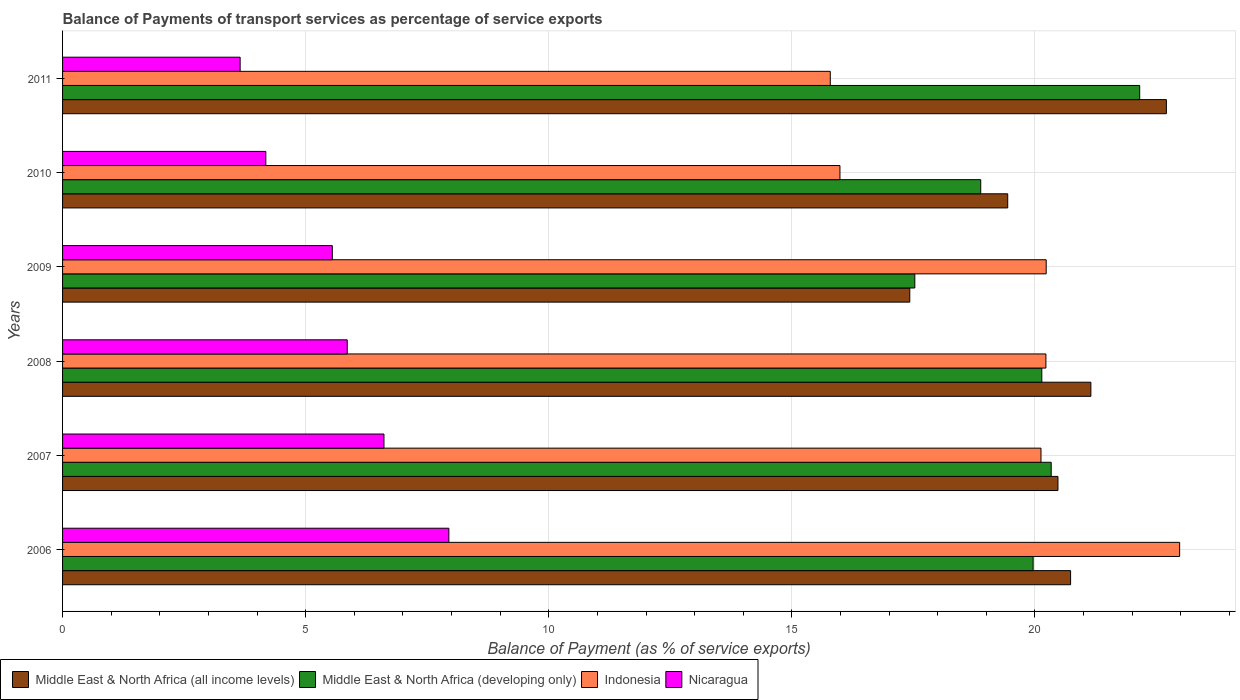How many groups of bars are there?
Offer a terse response. 6. Are the number of bars per tick equal to the number of legend labels?
Keep it short and to the point. Yes. How many bars are there on the 1st tick from the top?
Offer a terse response. 4. How many bars are there on the 4th tick from the bottom?
Make the answer very short. 4. What is the label of the 1st group of bars from the top?
Give a very brief answer. 2011. What is the balance of payments of transport services in Middle East & North Africa (developing only) in 2011?
Provide a succinct answer. 22.15. Across all years, what is the maximum balance of payments of transport services in Indonesia?
Provide a succinct answer. 22.98. Across all years, what is the minimum balance of payments of transport services in Middle East & North Africa (developing only)?
Offer a very short reply. 17.53. In which year was the balance of payments of transport services in Indonesia maximum?
Your answer should be compact. 2006. What is the total balance of payments of transport services in Middle East & North Africa (developing only) in the graph?
Offer a terse response. 119. What is the difference between the balance of payments of transport services in Nicaragua in 2007 and that in 2011?
Offer a terse response. 2.96. What is the difference between the balance of payments of transport services in Nicaragua in 2010 and the balance of payments of transport services in Middle East & North Africa (all income levels) in 2008?
Give a very brief answer. -16.97. What is the average balance of payments of transport services in Middle East & North Africa (developing only) per year?
Make the answer very short. 19.83. In the year 2010, what is the difference between the balance of payments of transport services in Middle East & North Africa (developing only) and balance of payments of transport services in Nicaragua?
Keep it short and to the point. 14.7. What is the ratio of the balance of payments of transport services in Nicaragua in 2006 to that in 2009?
Your answer should be very brief. 1.43. Is the balance of payments of transport services in Middle East & North Africa (developing only) in 2009 less than that in 2010?
Make the answer very short. Yes. What is the difference between the highest and the second highest balance of payments of transport services in Middle East & North Africa (all income levels)?
Ensure brevity in your answer.  1.55. What is the difference between the highest and the lowest balance of payments of transport services in Middle East & North Africa (developing only)?
Offer a terse response. 4.63. Is the sum of the balance of payments of transport services in Middle East & North Africa (all income levels) in 2009 and 2010 greater than the maximum balance of payments of transport services in Middle East & North Africa (developing only) across all years?
Ensure brevity in your answer.  Yes. Is it the case that in every year, the sum of the balance of payments of transport services in Middle East & North Africa (developing only) and balance of payments of transport services in Nicaragua is greater than the sum of balance of payments of transport services in Middle East & North Africa (all income levels) and balance of payments of transport services in Indonesia?
Offer a very short reply. Yes. What does the 4th bar from the bottom in 2010 represents?
Your answer should be compact. Nicaragua. How many years are there in the graph?
Give a very brief answer. 6. Are the values on the major ticks of X-axis written in scientific E-notation?
Ensure brevity in your answer.  No. Does the graph contain any zero values?
Make the answer very short. No. Does the graph contain grids?
Ensure brevity in your answer.  Yes. Where does the legend appear in the graph?
Your answer should be very brief. Bottom left. How many legend labels are there?
Provide a short and direct response. 4. How are the legend labels stacked?
Give a very brief answer. Horizontal. What is the title of the graph?
Offer a very short reply. Balance of Payments of transport services as percentage of service exports. What is the label or title of the X-axis?
Give a very brief answer. Balance of Payment (as % of service exports). What is the Balance of Payment (as % of service exports) in Middle East & North Africa (all income levels) in 2006?
Give a very brief answer. 20.73. What is the Balance of Payment (as % of service exports) of Middle East & North Africa (developing only) in 2006?
Provide a succinct answer. 19.96. What is the Balance of Payment (as % of service exports) of Indonesia in 2006?
Offer a terse response. 22.98. What is the Balance of Payment (as % of service exports) in Nicaragua in 2006?
Ensure brevity in your answer.  7.95. What is the Balance of Payment (as % of service exports) in Middle East & North Africa (all income levels) in 2007?
Offer a terse response. 20.47. What is the Balance of Payment (as % of service exports) in Middle East & North Africa (developing only) in 2007?
Provide a succinct answer. 20.33. What is the Balance of Payment (as % of service exports) of Indonesia in 2007?
Provide a short and direct response. 20.12. What is the Balance of Payment (as % of service exports) of Nicaragua in 2007?
Provide a short and direct response. 6.61. What is the Balance of Payment (as % of service exports) of Middle East & North Africa (all income levels) in 2008?
Provide a short and direct response. 21.15. What is the Balance of Payment (as % of service exports) in Middle East & North Africa (developing only) in 2008?
Offer a very short reply. 20.14. What is the Balance of Payment (as % of service exports) in Indonesia in 2008?
Give a very brief answer. 20.22. What is the Balance of Payment (as % of service exports) of Nicaragua in 2008?
Offer a very short reply. 5.85. What is the Balance of Payment (as % of service exports) of Middle East & North Africa (all income levels) in 2009?
Your response must be concise. 17.43. What is the Balance of Payment (as % of service exports) of Middle East & North Africa (developing only) in 2009?
Your response must be concise. 17.53. What is the Balance of Payment (as % of service exports) in Indonesia in 2009?
Keep it short and to the point. 20.23. What is the Balance of Payment (as % of service exports) in Nicaragua in 2009?
Provide a short and direct response. 5.55. What is the Balance of Payment (as % of service exports) of Middle East & North Africa (all income levels) in 2010?
Make the answer very short. 19.44. What is the Balance of Payment (as % of service exports) of Middle East & North Africa (developing only) in 2010?
Your response must be concise. 18.88. What is the Balance of Payment (as % of service exports) of Indonesia in 2010?
Provide a short and direct response. 15.99. What is the Balance of Payment (as % of service exports) of Nicaragua in 2010?
Your response must be concise. 4.18. What is the Balance of Payment (as % of service exports) in Middle East & North Africa (all income levels) in 2011?
Your answer should be compact. 22.7. What is the Balance of Payment (as % of service exports) in Middle East & North Africa (developing only) in 2011?
Your answer should be compact. 22.15. What is the Balance of Payment (as % of service exports) of Indonesia in 2011?
Offer a very short reply. 15.79. What is the Balance of Payment (as % of service exports) of Nicaragua in 2011?
Offer a very short reply. 3.65. Across all years, what is the maximum Balance of Payment (as % of service exports) in Middle East & North Africa (all income levels)?
Give a very brief answer. 22.7. Across all years, what is the maximum Balance of Payment (as % of service exports) of Middle East & North Africa (developing only)?
Offer a terse response. 22.15. Across all years, what is the maximum Balance of Payment (as % of service exports) of Indonesia?
Your response must be concise. 22.98. Across all years, what is the maximum Balance of Payment (as % of service exports) of Nicaragua?
Provide a short and direct response. 7.95. Across all years, what is the minimum Balance of Payment (as % of service exports) in Middle East & North Africa (all income levels)?
Offer a terse response. 17.43. Across all years, what is the minimum Balance of Payment (as % of service exports) of Middle East & North Africa (developing only)?
Provide a short and direct response. 17.53. Across all years, what is the minimum Balance of Payment (as % of service exports) in Indonesia?
Ensure brevity in your answer.  15.79. Across all years, what is the minimum Balance of Payment (as % of service exports) in Nicaragua?
Your answer should be compact. 3.65. What is the total Balance of Payment (as % of service exports) in Middle East & North Africa (all income levels) in the graph?
Make the answer very short. 121.92. What is the total Balance of Payment (as % of service exports) of Middle East & North Africa (developing only) in the graph?
Provide a short and direct response. 119. What is the total Balance of Payment (as % of service exports) of Indonesia in the graph?
Offer a very short reply. 115.33. What is the total Balance of Payment (as % of service exports) in Nicaragua in the graph?
Make the answer very short. 33.79. What is the difference between the Balance of Payment (as % of service exports) in Middle East & North Africa (all income levels) in 2006 and that in 2007?
Offer a terse response. 0.26. What is the difference between the Balance of Payment (as % of service exports) in Middle East & North Africa (developing only) in 2006 and that in 2007?
Offer a very short reply. -0.37. What is the difference between the Balance of Payment (as % of service exports) of Indonesia in 2006 and that in 2007?
Your answer should be very brief. 2.85. What is the difference between the Balance of Payment (as % of service exports) of Nicaragua in 2006 and that in 2007?
Offer a terse response. 1.33. What is the difference between the Balance of Payment (as % of service exports) in Middle East & North Africa (all income levels) in 2006 and that in 2008?
Ensure brevity in your answer.  -0.42. What is the difference between the Balance of Payment (as % of service exports) in Middle East & North Africa (developing only) in 2006 and that in 2008?
Offer a terse response. -0.18. What is the difference between the Balance of Payment (as % of service exports) in Indonesia in 2006 and that in 2008?
Your answer should be very brief. 2.75. What is the difference between the Balance of Payment (as % of service exports) of Nicaragua in 2006 and that in 2008?
Your answer should be compact. 2.09. What is the difference between the Balance of Payment (as % of service exports) of Middle East & North Africa (all income levels) in 2006 and that in 2009?
Provide a succinct answer. 3.31. What is the difference between the Balance of Payment (as % of service exports) in Middle East & North Africa (developing only) in 2006 and that in 2009?
Make the answer very short. 2.43. What is the difference between the Balance of Payment (as % of service exports) in Indonesia in 2006 and that in 2009?
Make the answer very short. 2.74. What is the difference between the Balance of Payment (as % of service exports) of Nicaragua in 2006 and that in 2009?
Your answer should be very brief. 2.4. What is the difference between the Balance of Payment (as % of service exports) of Middle East & North Africa (all income levels) in 2006 and that in 2010?
Offer a very short reply. 1.29. What is the difference between the Balance of Payment (as % of service exports) of Middle East & North Africa (developing only) in 2006 and that in 2010?
Keep it short and to the point. 1.08. What is the difference between the Balance of Payment (as % of service exports) in Indonesia in 2006 and that in 2010?
Offer a terse response. 6.99. What is the difference between the Balance of Payment (as % of service exports) in Nicaragua in 2006 and that in 2010?
Your response must be concise. 3.76. What is the difference between the Balance of Payment (as % of service exports) in Middle East & North Africa (all income levels) in 2006 and that in 2011?
Provide a succinct answer. -1.97. What is the difference between the Balance of Payment (as % of service exports) of Middle East & North Africa (developing only) in 2006 and that in 2011?
Offer a terse response. -2.19. What is the difference between the Balance of Payment (as % of service exports) of Indonesia in 2006 and that in 2011?
Your response must be concise. 7.19. What is the difference between the Balance of Payment (as % of service exports) of Nicaragua in 2006 and that in 2011?
Provide a succinct answer. 4.29. What is the difference between the Balance of Payment (as % of service exports) of Middle East & North Africa (all income levels) in 2007 and that in 2008?
Provide a short and direct response. -0.68. What is the difference between the Balance of Payment (as % of service exports) in Middle East & North Africa (developing only) in 2007 and that in 2008?
Ensure brevity in your answer.  0.19. What is the difference between the Balance of Payment (as % of service exports) of Indonesia in 2007 and that in 2008?
Provide a succinct answer. -0.1. What is the difference between the Balance of Payment (as % of service exports) in Nicaragua in 2007 and that in 2008?
Your answer should be compact. 0.76. What is the difference between the Balance of Payment (as % of service exports) of Middle East & North Africa (all income levels) in 2007 and that in 2009?
Provide a short and direct response. 3.05. What is the difference between the Balance of Payment (as % of service exports) in Middle East & North Africa (developing only) in 2007 and that in 2009?
Ensure brevity in your answer.  2.81. What is the difference between the Balance of Payment (as % of service exports) in Indonesia in 2007 and that in 2009?
Your answer should be compact. -0.11. What is the difference between the Balance of Payment (as % of service exports) of Nicaragua in 2007 and that in 2009?
Your answer should be compact. 1.06. What is the difference between the Balance of Payment (as % of service exports) of Middle East & North Africa (all income levels) in 2007 and that in 2010?
Your answer should be compact. 1.03. What is the difference between the Balance of Payment (as % of service exports) in Middle East & North Africa (developing only) in 2007 and that in 2010?
Your answer should be compact. 1.45. What is the difference between the Balance of Payment (as % of service exports) in Indonesia in 2007 and that in 2010?
Give a very brief answer. 4.13. What is the difference between the Balance of Payment (as % of service exports) in Nicaragua in 2007 and that in 2010?
Keep it short and to the point. 2.43. What is the difference between the Balance of Payment (as % of service exports) of Middle East & North Africa (all income levels) in 2007 and that in 2011?
Offer a very short reply. -2.23. What is the difference between the Balance of Payment (as % of service exports) in Middle East & North Africa (developing only) in 2007 and that in 2011?
Provide a succinct answer. -1.82. What is the difference between the Balance of Payment (as % of service exports) of Indonesia in 2007 and that in 2011?
Ensure brevity in your answer.  4.33. What is the difference between the Balance of Payment (as % of service exports) in Nicaragua in 2007 and that in 2011?
Your response must be concise. 2.96. What is the difference between the Balance of Payment (as % of service exports) in Middle East & North Africa (all income levels) in 2008 and that in 2009?
Offer a very short reply. 3.72. What is the difference between the Balance of Payment (as % of service exports) of Middle East & North Africa (developing only) in 2008 and that in 2009?
Your answer should be compact. 2.61. What is the difference between the Balance of Payment (as % of service exports) in Indonesia in 2008 and that in 2009?
Your answer should be very brief. -0.01. What is the difference between the Balance of Payment (as % of service exports) in Nicaragua in 2008 and that in 2009?
Offer a terse response. 0.31. What is the difference between the Balance of Payment (as % of service exports) of Middle East & North Africa (all income levels) in 2008 and that in 2010?
Offer a terse response. 1.71. What is the difference between the Balance of Payment (as % of service exports) in Middle East & North Africa (developing only) in 2008 and that in 2010?
Your answer should be very brief. 1.26. What is the difference between the Balance of Payment (as % of service exports) of Indonesia in 2008 and that in 2010?
Offer a very short reply. 4.24. What is the difference between the Balance of Payment (as % of service exports) of Nicaragua in 2008 and that in 2010?
Give a very brief answer. 1.67. What is the difference between the Balance of Payment (as % of service exports) in Middle East & North Africa (all income levels) in 2008 and that in 2011?
Ensure brevity in your answer.  -1.55. What is the difference between the Balance of Payment (as % of service exports) in Middle East & North Africa (developing only) in 2008 and that in 2011?
Your answer should be compact. -2.01. What is the difference between the Balance of Payment (as % of service exports) of Indonesia in 2008 and that in 2011?
Offer a terse response. 4.43. What is the difference between the Balance of Payment (as % of service exports) in Nicaragua in 2008 and that in 2011?
Provide a short and direct response. 2.2. What is the difference between the Balance of Payment (as % of service exports) in Middle East & North Africa (all income levels) in 2009 and that in 2010?
Your response must be concise. -2.01. What is the difference between the Balance of Payment (as % of service exports) in Middle East & North Africa (developing only) in 2009 and that in 2010?
Make the answer very short. -1.36. What is the difference between the Balance of Payment (as % of service exports) in Indonesia in 2009 and that in 2010?
Ensure brevity in your answer.  4.24. What is the difference between the Balance of Payment (as % of service exports) in Nicaragua in 2009 and that in 2010?
Your answer should be very brief. 1.37. What is the difference between the Balance of Payment (as % of service exports) of Middle East & North Africa (all income levels) in 2009 and that in 2011?
Your answer should be very brief. -5.28. What is the difference between the Balance of Payment (as % of service exports) of Middle East & North Africa (developing only) in 2009 and that in 2011?
Make the answer very short. -4.63. What is the difference between the Balance of Payment (as % of service exports) of Indonesia in 2009 and that in 2011?
Your answer should be very brief. 4.44. What is the difference between the Balance of Payment (as % of service exports) of Nicaragua in 2009 and that in 2011?
Provide a short and direct response. 1.9. What is the difference between the Balance of Payment (as % of service exports) of Middle East & North Africa (all income levels) in 2010 and that in 2011?
Your response must be concise. -3.26. What is the difference between the Balance of Payment (as % of service exports) of Middle East & North Africa (developing only) in 2010 and that in 2011?
Your answer should be very brief. -3.27. What is the difference between the Balance of Payment (as % of service exports) of Indonesia in 2010 and that in 2011?
Your answer should be very brief. 0.2. What is the difference between the Balance of Payment (as % of service exports) in Nicaragua in 2010 and that in 2011?
Keep it short and to the point. 0.53. What is the difference between the Balance of Payment (as % of service exports) in Middle East & North Africa (all income levels) in 2006 and the Balance of Payment (as % of service exports) in Middle East & North Africa (developing only) in 2007?
Keep it short and to the point. 0.4. What is the difference between the Balance of Payment (as % of service exports) of Middle East & North Africa (all income levels) in 2006 and the Balance of Payment (as % of service exports) of Indonesia in 2007?
Provide a short and direct response. 0.61. What is the difference between the Balance of Payment (as % of service exports) in Middle East & North Africa (all income levels) in 2006 and the Balance of Payment (as % of service exports) in Nicaragua in 2007?
Provide a succinct answer. 14.12. What is the difference between the Balance of Payment (as % of service exports) in Middle East & North Africa (developing only) in 2006 and the Balance of Payment (as % of service exports) in Indonesia in 2007?
Give a very brief answer. -0.16. What is the difference between the Balance of Payment (as % of service exports) of Middle East & North Africa (developing only) in 2006 and the Balance of Payment (as % of service exports) of Nicaragua in 2007?
Provide a short and direct response. 13.35. What is the difference between the Balance of Payment (as % of service exports) of Indonesia in 2006 and the Balance of Payment (as % of service exports) of Nicaragua in 2007?
Make the answer very short. 16.36. What is the difference between the Balance of Payment (as % of service exports) of Middle East & North Africa (all income levels) in 2006 and the Balance of Payment (as % of service exports) of Middle East & North Africa (developing only) in 2008?
Your response must be concise. 0.59. What is the difference between the Balance of Payment (as % of service exports) in Middle East & North Africa (all income levels) in 2006 and the Balance of Payment (as % of service exports) in Indonesia in 2008?
Your answer should be compact. 0.51. What is the difference between the Balance of Payment (as % of service exports) in Middle East & North Africa (all income levels) in 2006 and the Balance of Payment (as % of service exports) in Nicaragua in 2008?
Your response must be concise. 14.88. What is the difference between the Balance of Payment (as % of service exports) in Middle East & North Africa (developing only) in 2006 and the Balance of Payment (as % of service exports) in Indonesia in 2008?
Make the answer very short. -0.26. What is the difference between the Balance of Payment (as % of service exports) of Middle East & North Africa (developing only) in 2006 and the Balance of Payment (as % of service exports) of Nicaragua in 2008?
Keep it short and to the point. 14.11. What is the difference between the Balance of Payment (as % of service exports) of Indonesia in 2006 and the Balance of Payment (as % of service exports) of Nicaragua in 2008?
Provide a succinct answer. 17.12. What is the difference between the Balance of Payment (as % of service exports) in Middle East & North Africa (all income levels) in 2006 and the Balance of Payment (as % of service exports) in Middle East & North Africa (developing only) in 2009?
Your response must be concise. 3.2. What is the difference between the Balance of Payment (as % of service exports) of Middle East & North Africa (all income levels) in 2006 and the Balance of Payment (as % of service exports) of Indonesia in 2009?
Provide a succinct answer. 0.5. What is the difference between the Balance of Payment (as % of service exports) in Middle East & North Africa (all income levels) in 2006 and the Balance of Payment (as % of service exports) in Nicaragua in 2009?
Your response must be concise. 15.18. What is the difference between the Balance of Payment (as % of service exports) of Middle East & North Africa (developing only) in 2006 and the Balance of Payment (as % of service exports) of Indonesia in 2009?
Ensure brevity in your answer.  -0.27. What is the difference between the Balance of Payment (as % of service exports) of Middle East & North Africa (developing only) in 2006 and the Balance of Payment (as % of service exports) of Nicaragua in 2009?
Your answer should be compact. 14.41. What is the difference between the Balance of Payment (as % of service exports) in Indonesia in 2006 and the Balance of Payment (as % of service exports) in Nicaragua in 2009?
Your answer should be compact. 17.43. What is the difference between the Balance of Payment (as % of service exports) in Middle East & North Africa (all income levels) in 2006 and the Balance of Payment (as % of service exports) in Middle East & North Africa (developing only) in 2010?
Your response must be concise. 1.85. What is the difference between the Balance of Payment (as % of service exports) in Middle East & North Africa (all income levels) in 2006 and the Balance of Payment (as % of service exports) in Indonesia in 2010?
Offer a terse response. 4.74. What is the difference between the Balance of Payment (as % of service exports) in Middle East & North Africa (all income levels) in 2006 and the Balance of Payment (as % of service exports) in Nicaragua in 2010?
Give a very brief answer. 16.55. What is the difference between the Balance of Payment (as % of service exports) in Middle East & North Africa (developing only) in 2006 and the Balance of Payment (as % of service exports) in Indonesia in 2010?
Your answer should be very brief. 3.97. What is the difference between the Balance of Payment (as % of service exports) in Middle East & North Africa (developing only) in 2006 and the Balance of Payment (as % of service exports) in Nicaragua in 2010?
Offer a very short reply. 15.78. What is the difference between the Balance of Payment (as % of service exports) in Indonesia in 2006 and the Balance of Payment (as % of service exports) in Nicaragua in 2010?
Give a very brief answer. 18.8. What is the difference between the Balance of Payment (as % of service exports) in Middle East & North Africa (all income levels) in 2006 and the Balance of Payment (as % of service exports) in Middle East & North Africa (developing only) in 2011?
Your answer should be very brief. -1.42. What is the difference between the Balance of Payment (as % of service exports) of Middle East & North Africa (all income levels) in 2006 and the Balance of Payment (as % of service exports) of Indonesia in 2011?
Make the answer very short. 4.94. What is the difference between the Balance of Payment (as % of service exports) of Middle East & North Africa (all income levels) in 2006 and the Balance of Payment (as % of service exports) of Nicaragua in 2011?
Make the answer very short. 17.08. What is the difference between the Balance of Payment (as % of service exports) in Middle East & North Africa (developing only) in 2006 and the Balance of Payment (as % of service exports) in Indonesia in 2011?
Make the answer very short. 4.17. What is the difference between the Balance of Payment (as % of service exports) in Middle East & North Africa (developing only) in 2006 and the Balance of Payment (as % of service exports) in Nicaragua in 2011?
Ensure brevity in your answer.  16.31. What is the difference between the Balance of Payment (as % of service exports) of Indonesia in 2006 and the Balance of Payment (as % of service exports) of Nicaragua in 2011?
Make the answer very short. 19.32. What is the difference between the Balance of Payment (as % of service exports) of Middle East & North Africa (all income levels) in 2007 and the Balance of Payment (as % of service exports) of Middle East & North Africa (developing only) in 2008?
Keep it short and to the point. 0.33. What is the difference between the Balance of Payment (as % of service exports) in Middle East & North Africa (all income levels) in 2007 and the Balance of Payment (as % of service exports) in Indonesia in 2008?
Ensure brevity in your answer.  0.25. What is the difference between the Balance of Payment (as % of service exports) of Middle East & North Africa (all income levels) in 2007 and the Balance of Payment (as % of service exports) of Nicaragua in 2008?
Your answer should be very brief. 14.62. What is the difference between the Balance of Payment (as % of service exports) of Middle East & North Africa (developing only) in 2007 and the Balance of Payment (as % of service exports) of Indonesia in 2008?
Your answer should be compact. 0.11. What is the difference between the Balance of Payment (as % of service exports) of Middle East & North Africa (developing only) in 2007 and the Balance of Payment (as % of service exports) of Nicaragua in 2008?
Ensure brevity in your answer.  14.48. What is the difference between the Balance of Payment (as % of service exports) in Indonesia in 2007 and the Balance of Payment (as % of service exports) in Nicaragua in 2008?
Give a very brief answer. 14.27. What is the difference between the Balance of Payment (as % of service exports) in Middle East & North Africa (all income levels) in 2007 and the Balance of Payment (as % of service exports) in Middle East & North Africa (developing only) in 2009?
Give a very brief answer. 2.94. What is the difference between the Balance of Payment (as % of service exports) in Middle East & North Africa (all income levels) in 2007 and the Balance of Payment (as % of service exports) in Indonesia in 2009?
Make the answer very short. 0.24. What is the difference between the Balance of Payment (as % of service exports) in Middle East & North Africa (all income levels) in 2007 and the Balance of Payment (as % of service exports) in Nicaragua in 2009?
Your response must be concise. 14.92. What is the difference between the Balance of Payment (as % of service exports) in Middle East & North Africa (developing only) in 2007 and the Balance of Payment (as % of service exports) in Indonesia in 2009?
Your answer should be very brief. 0.1. What is the difference between the Balance of Payment (as % of service exports) of Middle East & North Africa (developing only) in 2007 and the Balance of Payment (as % of service exports) of Nicaragua in 2009?
Offer a terse response. 14.79. What is the difference between the Balance of Payment (as % of service exports) of Indonesia in 2007 and the Balance of Payment (as % of service exports) of Nicaragua in 2009?
Your response must be concise. 14.58. What is the difference between the Balance of Payment (as % of service exports) in Middle East & North Africa (all income levels) in 2007 and the Balance of Payment (as % of service exports) in Middle East & North Africa (developing only) in 2010?
Offer a terse response. 1.59. What is the difference between the Balance of Payment (as % of service exports) of Middle East & North Africa (all income levels) in 2007 and the Balance of Payment (as % of service exports) of Indonesia in 2010?
Your answer should be very brief. 4.48. What is the difference between the Balance of Payment (as % of service exports) in Middle East & North Africa (all income levels) in 2007 and the Balance of Payment (as % of service exports) in Nicaragua in 2010?
Your answer should be very brief. 16.29. What is the difference between the Balance of Payment (as % of service exports) of Middle East & North Africa (developing only) in 2007 and the Balance of Payment (as % of service exports) of Indonesia in 2010?
Give a very brief answer. 4.35. What is the difference between the Balance of Payment (as % of service exports) in Middle East & North Africa (developing only) in 2007 and the Balance of Payment (as % of service exports) in Nicaragua in 2010?
Your response must be concise. 16.15. What is the difference between the Balance of Payment (as % of service exports) of Indonesia in 2007 and the Balance of Payment (as % of service exports) of Nicaragua in 2010?
Keep it short and to the point. 15.94. What is the difference between the Balance of Payment (as % of service exports) of Middle East & North Africa (all income levels) in 2007 and the Balance of Payment (as % of service exports) of Middle East & North Africa (developing only) in 2011?
Give a very brief answer. -1.68. What is the difference between the Balance of Payment (as % of service exports) in Middle East & North Africa (all income levels) in 2007 and the Balance of Payment (as % of service exports) in Indonesia in 2011?
Make the answer very short. 4.68. What is the difference between the Balance of Payment (as % of service exports) of Middle East & North Africa (all income levels) in 2007 and the Balance of Payment (as % of service exports) of Nicaragua in 2011?
Offer a very short reply. 16.82. What is the difference between the Balance of Payment (as % of service exports) of Middle East & North Africa (developing only) in 2007 and the Balance of Payment (as % of service exports) of Indonesia in 2011?
Offer a very short reply. 4.54. What is the difference between the Balance of Payment (as % of service exports) in Middle East & North Africa (developing only) in 2007 and the Balance of Payment (as % of service exports) in Nicaragua in 2011?
Make the answer very short. 16.68. What is the difference between the Balance of Payment (as % of service exports) in Indonesia in 2007 and the Balance of Payment (as % of service exports) in Nicaragua in 2011?
Offer a terse response. 16.47. What is the difference between the Balance of Payment (as % of service exports) in Middle East & North Africa (all income levels) in 2008 and the Balance of Payment (as % of service exports) in Middle East & North Africa (developing only) in 2009?
Offer a terse response. 3.62. What is the difference between the Balance of Payment (as % of service exports) of Middle East & North Africa (all income levels) in 2008 and the Balance of Payment (as % of service exports) of Indonesia in 2009?
Give a very brief answer. 0.92. What is the difference between the Balance of Payment (as % of service exports) in Middle East & North Africa (all income levels) in 2008 and the Balance of Payment (as % of service exports) in Nicaragua in 2009?
Ensure brevity in your answer.  15.6. What is the difference between the Balance of Payment (as % of service exports) in Middle East & North Africa (developing only) in 2008 and the Balance of Payment (as % of service exports) in Indonesia in 2009?
Your answer should be very brief. -0.09. What is the difference between the Balance of Payment (as % of service exports) of Middle East & North Africa (developing only) in 2008 and the Balance of Payment (as % of service exports) of Nicaragua in 2009?
Your response must be concise. 14.59. What is the difference between the Balance of Payment (as % of service exports) of Indonesia in 2008 and the Balance of Payment (as % of service exports) of Nicaragua in 2009?
Provide a short and direct response. 14.68. What is the difference between the Balance of Payment (as % of service exports) in Middle East & North Africa (all income levels) in 2008 and the Balance of Payment (as % of service exports) in Middle East & North Africa (developing only) in 2010?
Provide a short and direct response. 2.27. What is the difference between the Balance of Payment (as % of service exports) of Middle East & North Africa (all income levels) in 2008 and the Balance of Payment (as % of service exports) of Indonesia in 2010?
Your answer should be very brief. 5.16. What is the difference between the Balance of Payment (as % of service exports) of Middle East & North Africa (all income levels) in 2008 and the Balance of Payment (as % of service exports) of Nicaragua in 2010?
Your answer should be very brief. 16.97. What is the difference between the Balance of Payment (as % of service exports) in Middle East & North Africa (developing only) in 2008 and the Balance of Payment (as % of service exports) in Indonesia in 2010?
Your answer should be very brief. 4.15. What is the difference between the Balance of Payment (as % of service exports) in Middle East & North Africa (developing only) in 2008 and the Balance of Payment (as % of service exports) in Nicaragua in 2010?
Provide a succinct answer. 15.96. What is the difference between the Balance of Payment (as % of service exports) of Indonesia in 2008 and the Balance of Payment (as % of service exports) of Nicaragua in 2010?
Your answer should be very brief. 16.04. What is the difference between the Balance of Payment (as % of service exports) in Middle East & North Africa (all income levels) in 2008 and the Balance of Payment (as % of service exports) in Middle East & North Africa (developing only) in 2011?
Your answer should be very brief. -1. What is the difference between the Balance of Payment (as % of service exports) of Middle East & North Africa (all income levels) in 2008 and the Balance of Payment (as % of service exports) of Indonesia in 2011?
Ensure brevity in your answer.  5.36. What is the difference between the Balance of Payment (as % of service exports) in Middle East & North Africa (all income levels) in 2008 and the Balance of Payment (as % of service exports) in Nicaragua in 2011?
Provide a succinct answer. 17.5. What is the difference between the Balance of Payment (as % of service exports) of Middle East & North Africa (developing only) in 2008 and the Balance of Payment (as % of service exports) of Indonesia in 2011?
Keep it short and to the point. 4.35. What is the difference between the Balance of Payment (as % of service exports) of Middle East & North Africa (developing only) in 2008 and the Balance of Payment (as % of service exports) of Nicaragua in 2011?
Keep it short and to the point. 16.49. What is the difference between the Balance of Payment (as % of service exports) in Indonesia in 2008 and the Balance of Payment (as % of service exports) in Nicaragua in 2011?
Your answer should be compact. 16.57. What is the difference between the Balance of Payment (as % of service exports) in Middle East & North Africa (all income levels) in 2009 and the Balance of Payment (as % of service exports) in Middle East & North Africa (developing only) in 2010?
Offer a very short reply. -1.46. What is the difference between the Balance of Payment (as % of service exports) in Middle East & North Africa (all income levels) in 2009 and the Balance of Payment (as % of service exports) in Indonesia in 2010?
Keep it short and to the point. 1.44. What is the difference between the Balance of Payment (as % of service exports) in Middle East & North Africa (all income levels) in 2009 and the Balance of Payment (as % of service exports) in Nicaragua in 2010?
Give a very brief answer. 13.24. What is the difference between the Balance of Payment (as % of service exports) in Middle East & North Africa (developing only) in 2009 and the Balance of Payment (as % of service exports) in Indonesia in 2010?
Provide a short and direct response. 1.54. What is the difference between the Balance of Payment (as % of service exports) of Middle East & North Africa (developing only) in 2009 and the Balance of Payment (as % of service exports) of Nicaragua in 2010?
Your answer should be very brief. 13.35. What is the difference between the Balance of Payment (as % of service exports) in Indonesia in 2009 and the Balance of Payment (as % of service exports) in Nicaragua in 2010?
Offer a terse response. 16.05. What is the difference between the Balance of Payment (as % of service exports) of Middle East & North Africa (all income levels) in 2009 and the Balance of Payment (as % of service exports) of Middle East & North Africa (developing only) in 2011?
Keep it short and to the point. -4.73. What is the difference between the Balance of Payment (as % of service exports) of Middle East & North Africa (all income levels) in 2009 and the Balance of Payment (as % of service exports) of Indonesia in 2011?
Provide a succinct answer. 1.64. What is the difference between the Balance of Payment (as % of service exports) in Middle East & North Africa (all income levels) in 2009 and the Balance of Payment (as % of service exports) in Nicaragua in 2011?
Your answer should be compact. 13.77. What is the difference between the Balance of Payment (as % of service exports) of Middle East & North Africa (developing only) in 2009 and the Balance of Payment (as % of service exports) of Indonesia in 2011?
Your answer should be very brief. 1.74. What is the difference between the Balance of Payment (as % of service exports) in Middle East & North Africa (developing only) in 2009 and the Balance of Payment (as % of service exports) in Nicaragua in 2011?
Ensure brevity in your answer.  13.88. What is the difference between the Balance of Payment (as % of service exports) of Indonesia in 2009 and the Balance of Payment (as % of service exports) of Nicaragua in 2011?
Your answer should be compact. 16.58. What is the difference between the Balance of Payment (as % of service exports) of Middle East & North Africa (all income levels) in 2010 and the Balance of Payment (as % of service exports) of Middle East & North Africa (developing only) in 2011?
Keep it short and to the point. -2.71. What is the difference between the Balance of Payment (as % of service exports) of Middle East & North Africa (all income levels) in 2010 and the Balance of Payment (as % of service exports) of Indonesia in 2011?
Give a very brief answer. 3.65. What is the difference between the Balance of Payment (as % of service exports) in Middle East & North Africa (all income levels) in 2010 and the Balance of Payment (as % of service exports) in Nicaragua in 2011?
Your answer should be compact. 15.79. What is the difference between the Balance of Payment (as % of service exports) of Middle East & North Africa (developing only) in 2010 and the Balance of Payment (as % of service exports) of Indonesia in 2011?
Offer a very short reply. 3.09. What is the difference between the Balance of Payment (as % of service exports) in Middle East & North Africa (developing only) in 2010 and the Balance of Payment (as % of service exports) in Nicaragua in 2011?
Offer a terse response. 15.23. What is the difference between the Balance of Payment (as % of service exports) in Indonesia in 2010 and the Balance of Payment (as % of service exports) in Nicaragua in 2011?
Give a very brief answer. 12.34. What is the average Balance of Payment (as % of service exports) of Middle East & North Africa (all income levels) per year?
Provide a succinct answer. 20.32. What is the average Balance of Payment (as % of service exports) in Middle East & North Africa (developing only) per year?
Ensure brevity in your answer.  19.83. What is the average Balance of Payment (as % of service exports) of Indonesia per year?
Offer a very short reply. 19.22. What is the average Balance of Payment (as % of service exports) of Nicaragua per year?
Offer a terse response. 5.63. In the year 2006, what is the difference between the Balance of Payment (as % of service exports) of Middle East & North Africa (all income levels) and Balance of Payment (as % of service exports) of Middle East & North Africa (developing only)?
Ensure brevity in your answer.  0.77. In the year 2006, what is the difference between the Balance of Payment (as % of service exports) of Middle East & North Africa (all income levels) and Balance of Payment (as % of service exports) of Indonesia?
Provide a succinct answer. -2.24. In the year 2006, what is the difference between the Balance of Payment (as % of service exports) in Middle East & North Africa (all income levels) and Balance of Payment (as % of service exports) in Nicaragua?
Offer a very short reply. 12.79. In the year 2006, what is the difference between the Balance of Payment (as % of service exports) of Middle East & North Africa (developing only) and Balance of Payment (as % of service exports) of Indonesia?
Offer a terse response. -3.01. In the year 2006, what is the difference between the Balance of Payment (as % of service exports) in Middle East & North Africa (developing only) and Balance of Payment (as % of service exports) in Nicaragua?
Make the answer very short. 12.02. In the year 2006, what is the difference between the Balance of Payment (as % of service exports) of Indonesia and Balance of Payment (as % of service exports) of Nicaragua?
Make the answer very short. 15.03. In the year 2007, what is the difference between the Balance of Payment (as % of service exports) of Middle East & North Africa (all income levels) and Balance of Payment (as % of service exports) of Middle East & North Africa (developing only)?
Provide a succinct answer. 0.14. In the year 2007, what is the difference between the Balance of Payment (as % of service exports) in Middle East & North Africa (all income levels) and Balance of Payment (as % of service exports) in Indonesia?
Ensure brevity in your answer.  0.35. In the year 2007, what is the difference between the Balance of Payment (as % of service exports) in Middle East & North Africa (all income levels) and Balance of Payment (as % of service exports) in Nicaragua?
Make the answer very short. 13.86. In the year 2007, what is the difference between the Balance of Payment (as % of service exports) in Middle East & North Africa (developing only) and Balance of Payment (as % of service exports) in Indonesia?
Provide a succinct answer. 0.21. In the year 2007, what is the difference between the Balance of Payment (as % of service exports) in Middle East & North Africa (developing only) and Balance of Payment (as % of service exports) in Nicaragua?
Provide a short and direct response. 13.72. In the year 2007, what is the difference between the Balance of Payment (as % of service exports) in Indonesia and Balance of Payment (as % of service exports) in Nicaragua?
Provide a short and direct response. 13.51. In the year 2008, what is the difference between the Balance of Payment (as % of service exports) in Middle East & North Africa (all income levels) and Balance of Payment (as % of service exports) in Middle East & North Africa (developing only)?
Offer a very short reply. 1.01. In the year 2008, what is the difference between the Balance of Payment (as % of service exports) of Middle East & North Africa (all income levels) and Balance of Payment (as % of service exports) of Indonesia?
Offer a very short reply. 0.93. In the year 2008, what is the difference between the Balance of Payment (as % of service exports) of Middle East & North Africa (all income levels) and Balance of Payment (as % of service exports) of Nicaragua?
Ensure brevity in your answer.  15.3. In the year 2008, what is the difference between the Balance of Payment (as % of service exports) in Middle East & North Africa (developing only) and Balance of Payment (as % of service exports) in Indonesia?
Your response must be concise. -0.08. In the year 2008, what is the difference between the Balance of Payment (as % of service exports) of Middle East & North Africa (developing only) and Balance of Payment (as % of service exports) of Nicaragua?
Offer a terse response. 14.29. In the year 2008, what is the difference between the Balance of Payment (as % of service exports) of Indonesia and Balance of Payment (as % of service exports) of Nicaragua?
Offer a terse response. 14.37. In the year 2009, what is the difference between the Balance of Payment (as % of service exports) in Middle East & North Africa (all income levels) and Balance of Payment (as % of service exports) in Middle East & North Africa (developing only)?
Provide a succinct answer. -0.1. In the year 2009, what is the difference between the Balance of Payment (as % of service exports) of Middle East & North Africa (all income levels) and Balance of Payment (as % of service exports) of Indonesia?
Make the answer very short. -2.81. In the year 2009, what is the difference between the Balance of Payment (as % of service exports) in Middle East & North Africa (all income levels) and Balance of Payment (as % of service exports) in Nicaragua?
Your answer should be very brief. 11.88. In the year 2009, what is the difference between the Balance of Payment (as % of service exports) of Middle East & North Africa (developing only) and Balance of Payment (as % of service exports) of Indonesia?
Give a very brief answer. -2.7. In the year 2009, what is the difference between the Balance of Payment (as % of service exports) of Middle East & North Africa (developing only) and Balance of Payment (as % of service exports) of Nicaragua?
Provide a short and direct response. 11.98. In the year 2009, what is the difference between the Balance of Payment (as % of service exports) of Indonesia and Balance of Payment (as % of service exports) of Nicaragua?
Your response must be concise. 14.68. In the year 2010, what is the difference between the Balance of Payment (as % of service exports) of Middle East & North Africa (all income levels) and Balance of Payment (as % of service exports) of Middle East & North Africa (developing only)?
Offer a terse response. 0.56. In the year 2010, what is the difference between the Balance of Payment (as % of service exports) in Middle East & North Africa (all income levels) and Balance of Payment (as % of service exports) in Indonesia?
Your answer should be very brief. 3.45. In the year 2010, what is the difference between the Balance of Payment (as % of service exports) of Middle East & North Africa (all income levels) and Balance of Payment (as % of service exports) of Nicaragua?
Offer a very short reply. 15.26. In the year 2010, what is the difference between the Balance of Payment (as % of service exports) of Middle East & North Africa (developing only) and Balance of Payment (as % of service exports) of Indonesia?
Offer a very short reply. 2.9. In the year 2010, what is the difference between the Balance of Payment (as % of service exports) of Middle East & North Africa (developing only) and Balance of Payment (as % of service exports) of Nicaragua?
Provide a succinct answer. 14.7. In the year 2010, what is the difference between the Balance of Payment (as % of service exports) in Indonesia and Balance of Payment (as % of service exports) in Nicaragua?
Your answer should be compact. 11.81. In the year 2011, what is the difference between the Balance of Payment (as % of service exports) in Middle East & North Africa (all income levels) and Balance of Payment (as % of service exports) in Middle East & North Africa (developing only)?
Ensure brevity in your answer.  0.55. In the year 2011, what is the difference between the Balance of Payment (as % of service exports) in Middle East & North Africa (all income levels) and Balance of Payment (as % of service exports) in Indonesia?
Offer a terse response. 6.91. In the year 2011, what is the difference between the Balance of Payment (as % of service exports) of Middle East & North Africa (all income levels) and Balance of Payment (as % of service exports) of Nicaragua?
Your response must be concise. 19.05. In the year 2011, what is the difference between the Balance of Payment (as % of service exports) in Middle East & North Africa (developing only) and Balance of Payment (as % of service exports) in Indonesia?
Your answer should be compact. 6.36. In the year 2011, what is the difference between the Balance of Payment (as % of service exports) in Middle East & North Africa (developing only) and Balance of Payment (as % of service exports) in Nicaragua?
Your answer should be very brief. 18.5. In the year 2011, what is the difference between the Balance of Payment (as % of service exports) in Indonesia and Balance of Payment (as % of service exports) in Nicaragua?
Make the answer very short. 12.14. What is the ratio of the Balance of Payment (as % of service exports) in Middle East & North Africa (all income levels) in 2006 to that in 2007?
Give a very brief answer. 1.01. What is the ratio of the Balance of Payment (as % of service exports) in Middle East & North Africa (developing only) in 2006 to that in 2007?
Provide a succinct answer. 0.98. What is the ratio of the Balance of Payment (as % of service exports) in Indonesia in 2006 to that in 2007?
Offer a terse response. 1.14. What is the ratio of the Balance of Payment (as % of service exports) in Nicaragua in 2006 to that in 2007?
Offer a terse response. 1.2. What is the ratio of the Balance of Payment (as % of service exports) in Middle East & North Africa (all income levels) in 2006 to that in 2008?
Keep it short and to the point. 0.98. What is the ratio of the Balance of Payment (as % of service exports) of Middle East & North Africa (developing only) in 2006 to that in 2008?
Your answer should be very brief. 0.99. What is the ratio of the Balance of Payment (as % of service exports) of Indonesia in 2006 to that in 2008?
Your answer should be compact. 1.14. What is the ratio of the Balance of Payment (as % of service exports) of Nicaragua in 2006 to that in 2008?
Offer a terse response. 1.36. What is the ratio of the Balance of Payment (as % of service exports) of Middle East & North Africa (all income levels) in 2006 to that in 2009?
Provide a succinct answer. 1.19. What is the ratio of the Balance of Payment (as % of service exports) in Middle East & North Africa (developing only) in 2006 to that in 2009?
Give a very brief answer. 1.14. What is the ratio of the Balance of Payment (as % of service exports) in Indonesia in 2006 to that in 2009?
Offer a terse response. 1.14. What is the ratio of the Balance of Payment (as % of service exports) of Nicaragua in 2006 to that in 2009?
Provide a succinct answer. 1.43. What is the ratio of the Balance of Payment (as % of service exports) of Middle East & North Africa (all income levels) in 2006 to that in 2010?
Offer a very short reply. 1.07. What is the ratio of the Balance of Payment (as % of service exports) in Middle East & North Africa (developing only) in 2006 to that in 2010?
Ensure brevity in your answer.  1.06. What is the ratio of the Balance of Payment (as % of service exports) in Indonesia in 2006 to that in 2010?
Keep it short and to the point. 1.44. What is the ratio of the Balance of Payment (as % of service exports) of Nicaragua in 2006 to that in 2010?
Your answer should be very brief. 1.9. What is the ratio of the Balance of Payment (as % of service exports) of Middle East & North Africa (all income levels) in 2006 to that in 2011?
Provide a succinct answer. 0.91. What is the ratio of the Balance of Payment (as % of service exports) in Middle East & North Africa (developing only) in 2006 to that in 2011?
Provide a succinct answer. 0.9. What is the ratio of the Balance of Payment (as % of service exports) of Indonesia in 2006 to that in 2011?
Give a very brief answer. 1.46. What is the ratio of the Balance of Payment (as % of service exports) of Nicaragua in 2006 to that in 2011?
Keep it short and to the point. 2.18. What is the ratio of the Balance of Payment (as % of service exports) in Middle East & North Africa (all income levels) in 2007 to that in 2008?
Your answer should be very brief. 0.97. What is the ratio of the Balance of Payment (as % of service exports) in Middle East & North Africa (developing only) in 2007 to that in 2008?
Your answer should be very brief. 1.01. What is the ratio of the Balance of Payment (as % of service exports) of Nicaragua in 2007 to that in 2008?
Ensure brevity in your answer.  1.13. What is the ratio of the Balance of Payment (as % of service exports) of Middle East & North Africa (all income levels) in 2007 to that in 2009?
Ensure brevity in your answer.  1.17. What is the ratio of the Balance of Payment (as % of service exports) of Middle East & North Africa (developing only) in 2007 to that in 2009?
Offer a very short reply. 1.16. What is the ratio of the Balance of Payment (as % of service exports) of Indonesia in 2007 to that in 2009?
Give a very brief answer. 0.99. What is the ratio of the Balance of Payment (as % of service exports) of Nicaragua in 2007 to that in 2009?
Keep it short and to the point. 1.19. What is the ratio of the Balance of Payment (as % of service exports) in Middle East & North Africa (all income levels) in 2007 to that in 2010?
Offer a very short reply. 1.05. What is the ratio of the Balance of Payment (as % of service exports) of Middle East & North Africa (developing only) in 2007 to that in 2010?
Provide a succinct answer. 1.08. What is the ratio of the Balance of Payment (as % of service exports) of Indonesia in 2007 to that in 2010?
Provide a short and direct response. 1.26. What is the ratio of the Balance of Payment (as % of service exports) in Nicaragua in 2007 to that in 2010?
Ensure brevity in your answer.  1.58. What is the ratio of the Balance of Payment (as % of service exports) in Middle East & North Africa (all income levels) in 2007 to that in 2011?
Give a very brief answer. 0.9. What is the ratio of the Balance of Payment (as % of service exports) in Middle East & North Africa (developing only) in 2007 to that in 2011?
Offer a terse response. 0.92. What is the ratio of the Balance of Payment (as % of service exports) of Indonesia in 2007 to that in 2011?
Ensure brevity in your answer.  1.27. What is the ratio of the Balance of Payment (as % of service exports) in Nicaragua in 2007 to that in 2011?
Ensure brevity in your answer.  1.81. What is the ratio of the Balance of Payment (as % of service exports) in Middle East & North Africa (all income levels) in 2008 to that in 2009?
Provide a succinct answer. 1.21. What is the ratio of the Balance of Payment (as % of service exports) in Middle East & North Africa (developing only) in 2008 to that in 2009?
Make the answer very short. 1.15. What is the ratio of the Balance of Payment (as % of service exports) of Indonesia in 2008 to that in 2009?
Make the answer very short. 1. What is the ratio of the Balance of Payment (as % of service exports) in Nicaragua in 2008 to that in 2009?
Offer a very short reply. 1.06. What is the ratio of the Balance of Payment (as % of service exports) in Middle East & North Africa (all income levels) in 2008 to that in 2010?
Provide a short and direct response. 1.09. What is the ratio of the Balance of Payment (as % of service exports) of Middle East & North Africa (developing only) in 2008 to that in 2010?
Make the answer very short. 1.07. What is the ratio of the Balance of Payment (as % of service exports) of Indonesia in 2008 to that in 2010?
Offer a very short reply. 1.26. What is the ratio of the Balance of Payment (as % of service exports) of Nicaragua in 2008 to that in 2010?
Provide a short and direct response. 1.4. What is the ratio of the Balance of Payment (as % of service exports) in Middle East & North Africa (all income levels) in 2008 to that in 2011?
Your answer should be very brief. 0.93. What is the ratio of the Balance of Payment (as % of service exports) of Indonesia in 2008 to that in 2011?
Ensure brevity in your answer.  1.28. What is the ratio of the Balance of Payment (as % of service exports) of Nicaragua in 2008 to that in 2011?
Your answer should be compact. 1.6. What is the ratio of the Balance of Payment (as % of service exports) in Middle East & North Africa (all income levels) in 2009 to that in 2010?
Offer a terse response. 0.9. What is the ratio of the Balance of Payment (as % of service exports) of Middle East & North Africa (developing only) in 2009 to that in 2010?
Offer a very short reply. 0.93. What is the ratio of the Balance of Payment (as % of service exports) of Indonesia in 2009 to that in 2010?
Make the answer very short. 1.27. What is the ratio of the Balance of Payment (as % of service exports) in Nicaragua in 2009 to that in 2010?
Keep it short and to the point. 1.33. What is the ratio of the Balance of Payment (as % of service exports) of Middle East & North Africa (all income levels) in 2009 to that in 2011?
Give a very brief answer. 0.77. What is the ratio of the Balance of Payment (as % of service exports) in Middle East & North Africa (developing only) in 2009 to that in 2011?
Offer a terse response. 0.79. What is the ratio of the Balance of Payment (as % of service exports) in Indonesia in 2009 to that in 2011?
Provide a succinct answer. 1.28. What is the ratio of the Balance of Payment (as % of service exports) in Nicaragua in 2009 to that in 2011?
Your response must be concise. 1.52. What is the ratio of the Balance of Payment (as % of service exports) in Middle East & North Africa (all income levels) in 2010 to that in 2011?
Make the answer very short. 0.86. What is the ratio of the Balance of Payment (as % of service exports) in Middle East & North Africa (developing only) in 2010 to that in 2011?
Offer a very short reply. 0.85. What is the ratio of the Balance of Payment (as % of service exports) in Indonesia in 2010 to that in 2011?
Provide a short and direct response. 1.01. What is the ratio of the Balance of Payment (as % of service exports) in Nicaragua in 2010 to that in 2011?
Give a very brief answer. 1.14. What is the difference between the highest and the second highest Balance of Payment (as % of service exports) of Middle East & North Africa (all income levels)?
Provide a succinct answer. 1.55. What is the difference between the highest and the second highest Balance of Payment (as % of service exports) in Middle East & North Africa (developing only)?
Keep it short and to the point. 1.82. What is the difference between the highest and the second highest Balance of Payment (as % of service exports) of Indonesia?
Your response must be concise. 2.74. What is the difference between the highest and the second highest Balance of Payment (as % of service exports) in Nicaragua?
Your answer should be very brief. 1.33. What is the difference between the highest and the lowest Balance of Payment (as % of service exports) of Middle East & North Africa (all income levels)?
Make the answer very short. 5.28. What is the difference between the highest and the lowest Balance of Payment (as % of service exports) of Middle East & North Africa (developing only)?
Offer a very short reply. 4.63. What is the difference between the highest and the lowest Balance of Payment (as % of service exports) of Indonesia?
Provide a short and direct response. 7.19. What is the difference between the highest and the lowest Balance of Payment (as % of service exports) in Nicaragua?
Keep it short and to the point. 4.29. 